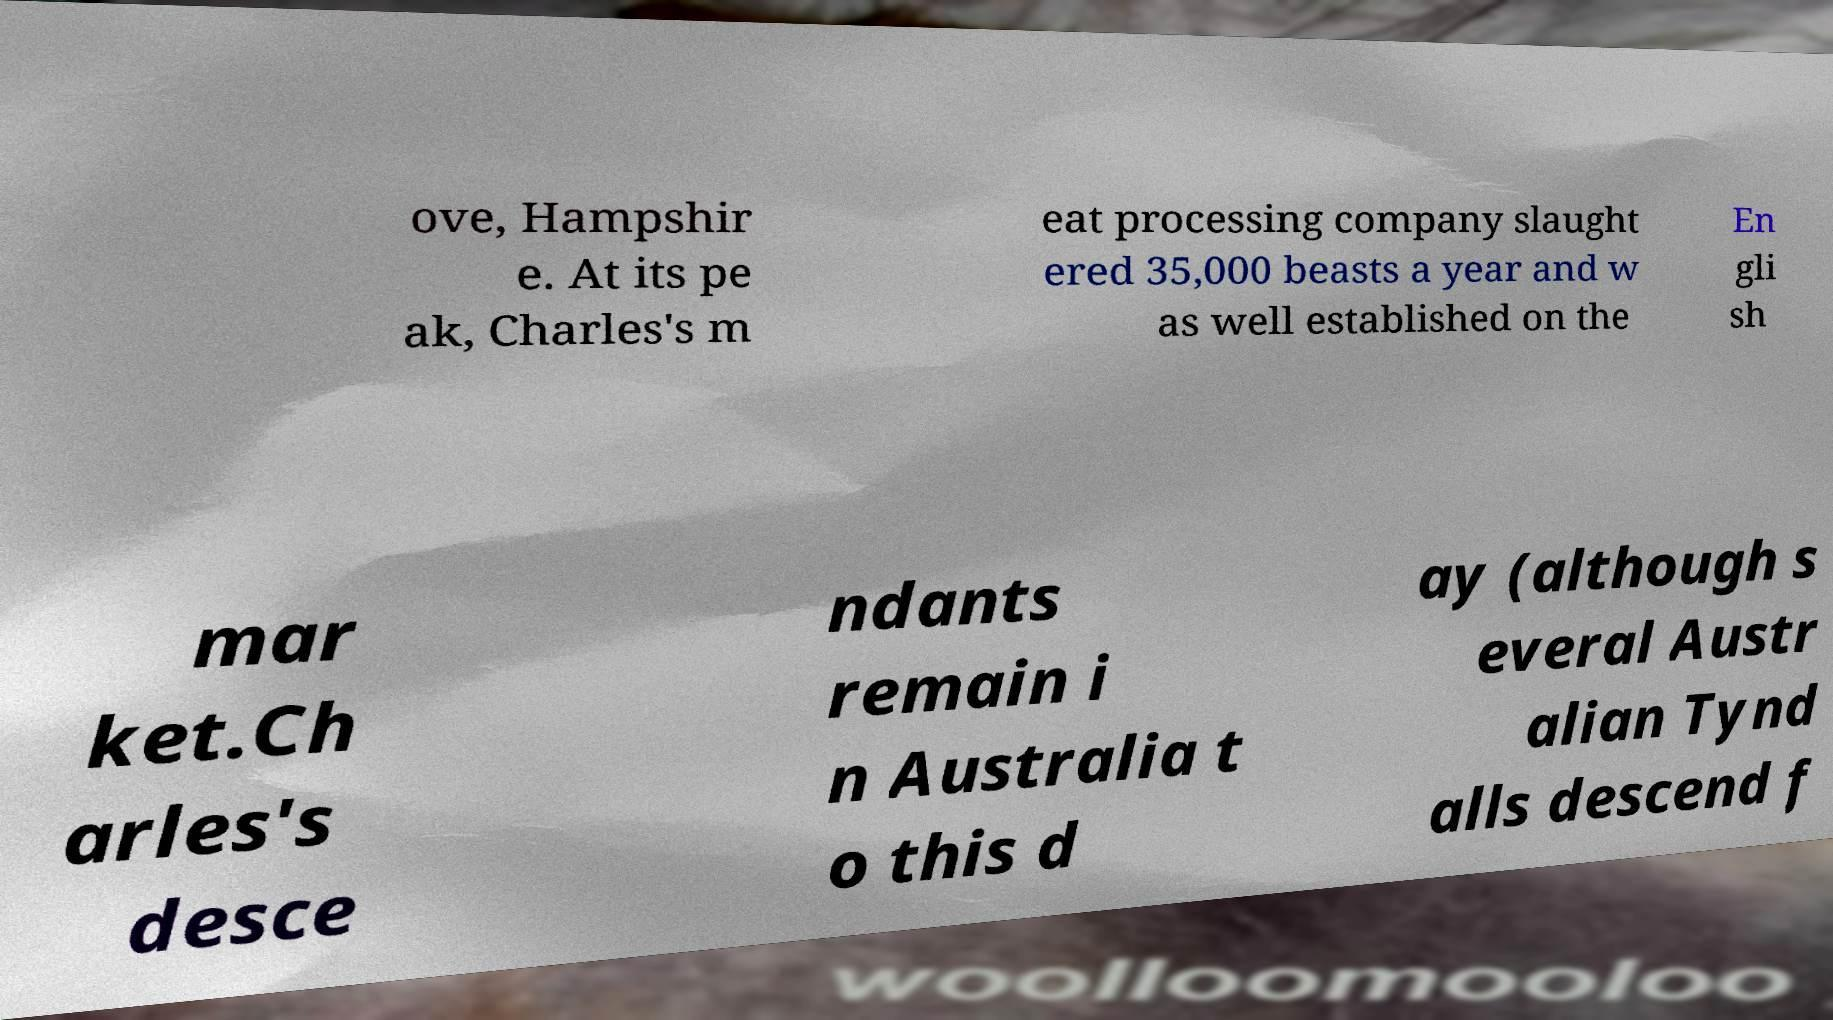Can you read and provide the text displayed in the image?This photo seems to have some interesting text. Can you extract and type it out for me? ove, Hampshir e. At its pe ak, Charles's m eat processing company slaught ered 35,000 beasts a year and w as well established on the En gli sh mar ket.Ch arles's desce ndants remain i n Australia t o this d ay (although s everal Austr alian Tynd alls descend f 